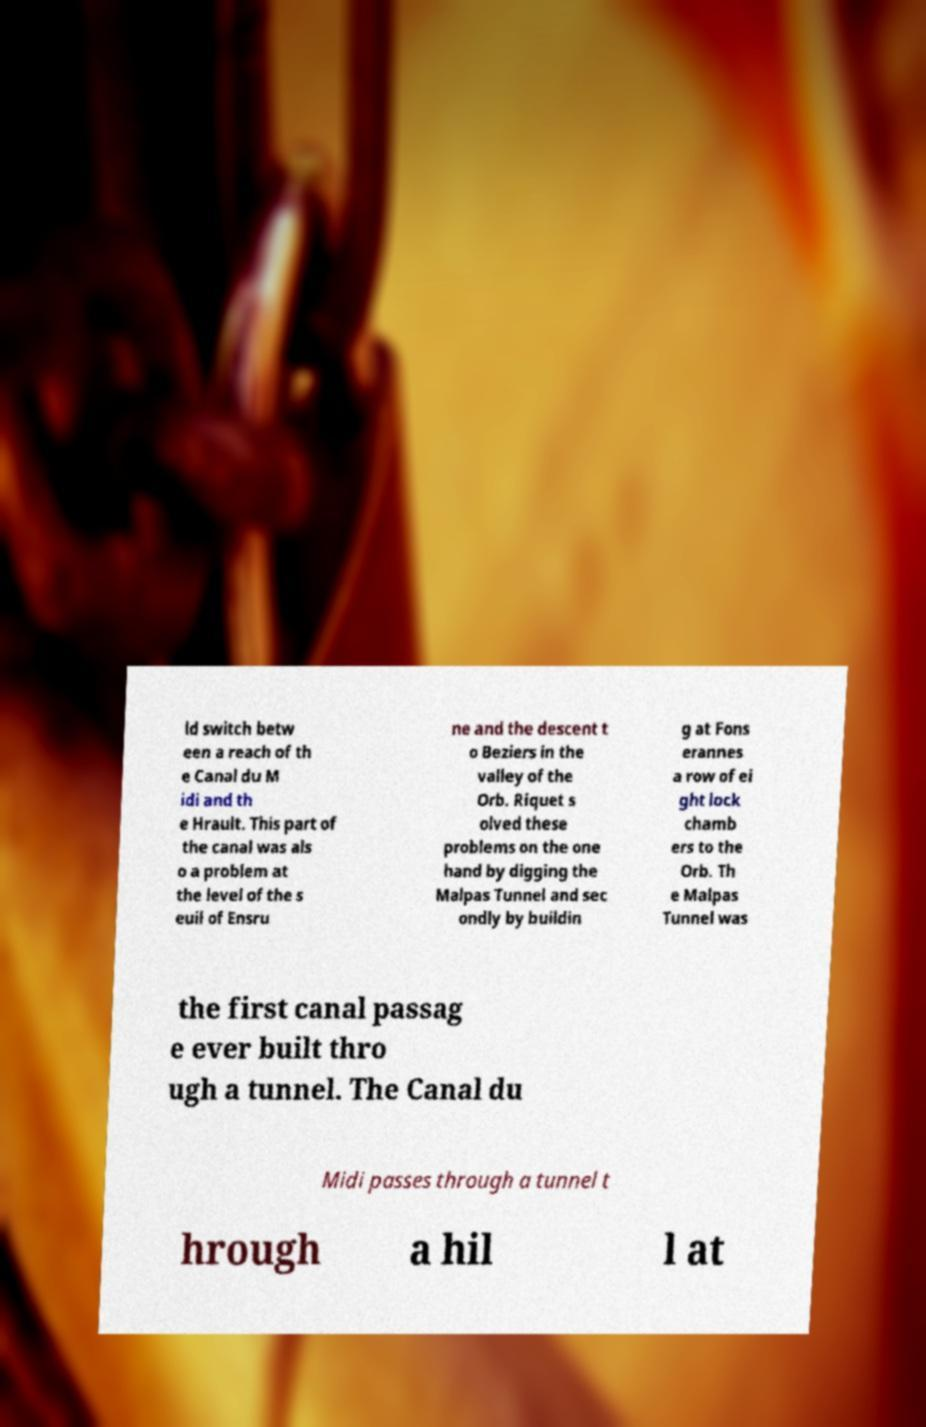Can you accurately transcribe the text from the provided image for me? ld switch betw een a reach of th e Canal du M idi and th e Hrault. This part of the canal was als o a problem at the level of the s euil of Ensru ne and the descent t o Beziers in the valley of the Orb. Riquet s olved these problems on the one hand by digging the Malpas Tunnel and sec ondly by buildin g at Fons erannes a row of ei ght lock chamb ers to the Orb. Th e Malpas Tunnel was the first canal passag e ever built thro ugh a tunnel. The Canal du Midi passes through a tunnel t hrough a hil l at 